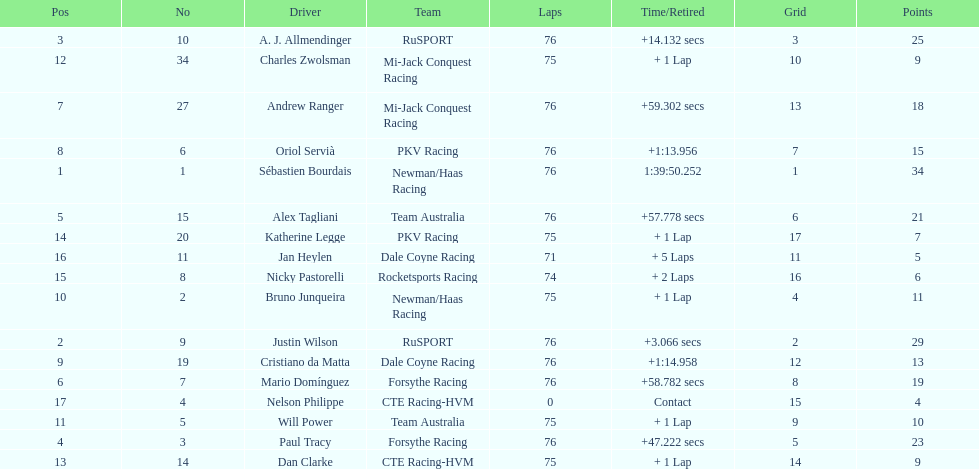What was the total points that canada earned together? 62. 